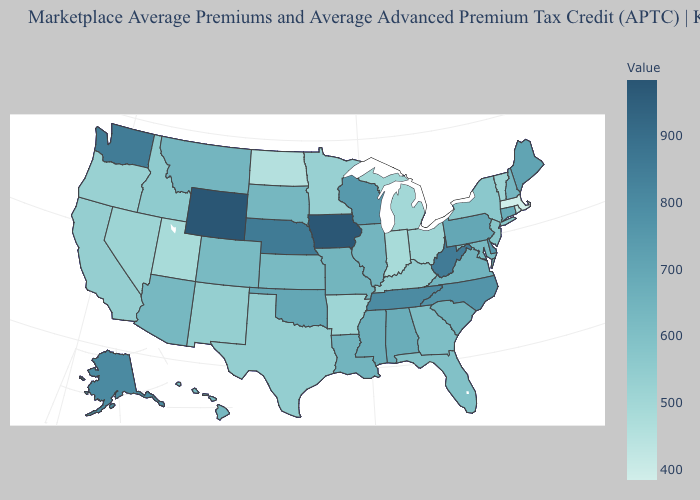Which states have the highest value in the USA?
Keep it brief. Wyoming. Does Maine have the highest value in the Northeast?
Answer briefly. Yes. Does Indiana have a lower value than Rhode Island?
Write a very short answer. No. Does Alaska have a higher value than Iowa?
Give a very brief answer. No. Is the legend a continuous bar?
Give a very brief answer. Yes. 